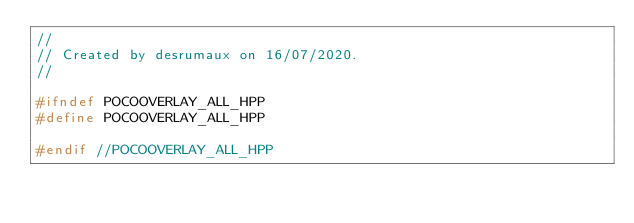Convert code to text. <code><loc_0><loc_0><loc_500><loc_500><_C++_>//
// Created by desrumaux on 16/07/2020.
//

#ifndef POCOOVERLAY_ALL_HPP
#define POCOOVERLAY_ALL_HPP

#endif //POCOOVERLAY_ALL_HPP
</code> 